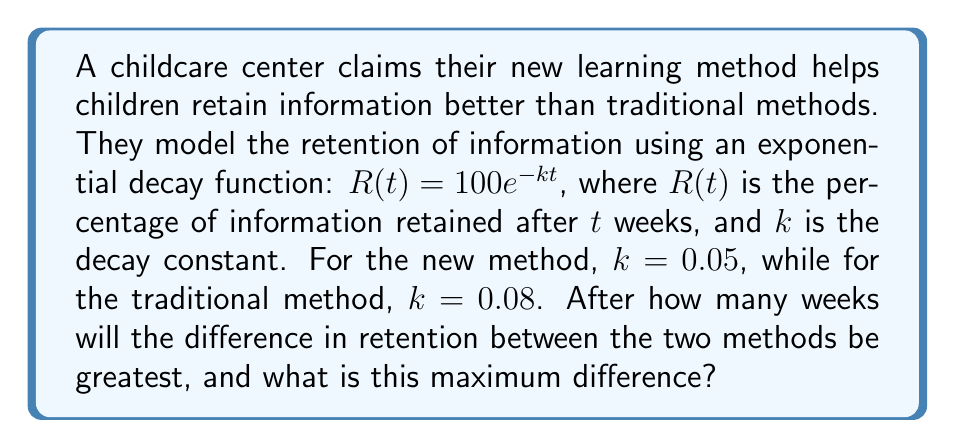Can you solve this math problem? Let's approach this step-by-step:

1) For the new method: $R_n(t) = 100e^{-0.05t}$
   For the traditional method: $R_t(t) = 100e^{-0.08t}$

2) The difference in retention is:
   $D(t) = R_n(t) - R_t(t) = 100e^{-0.05t} - 100e^{-0.08t}$

3) To find the maximum difference, we need to find where the derivative of $D(t)$ equals zero:
   $\frac{dD}{dt} = -5e^{-0.05t} + 8e^{-0.08t}$

4) Set this equal to zero:
   $-5e^{-0.05t} + 8e^{-0.08t} = 0$

5) Solve for $t$:
   $5e^{-0.05t} = 8e^{-0.08t}$
   $\ln(5) - 0.05t = \ln(8) - 0.08t$
   $0.03t = \ln(8) - \ln(5)$
   $t = \frac{\ln(8/5)}{0.03} \approx 15.4$ weeks

6) The maximum difference occurs at approximately 15.4 weeks.

7) To find the maximum difference, plug this value back into $D(t)$:
   $D(15.4) = 100e^{-0.05(15.4)} - 100e^{-0.08(15.4)} \approx 46.3 - 29.2 = 17.1$

Therefore, the maximum difference in retention is about 17.1 percentage points, occurring at approximately 15.4 weeks.
Answer: 15.4 weeks; 17.1 percentage points 